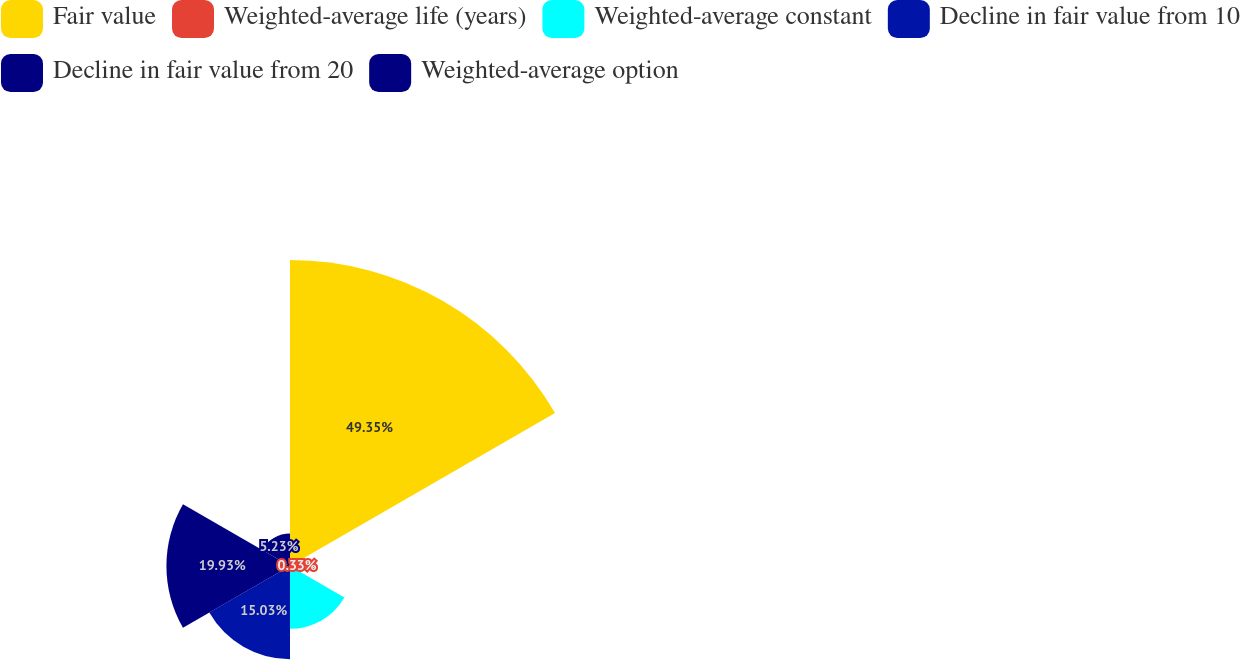<chart> <loc_0><loc_0><loc_500><loc_500><pie_chart><fcel>Fair value<fcel>Weighted-average life (years)<fcel>Weighted-average constant<fcel>Decline in fair value from 10<fcel>Decline in fair value from 20<fcel>Weighted-average option<nl><fcel>49.35%<fcel>0.33%<fcel>10.13%<fcel>15.03%<fcel>19.93%<fcel>5.23%<nl></chart> 